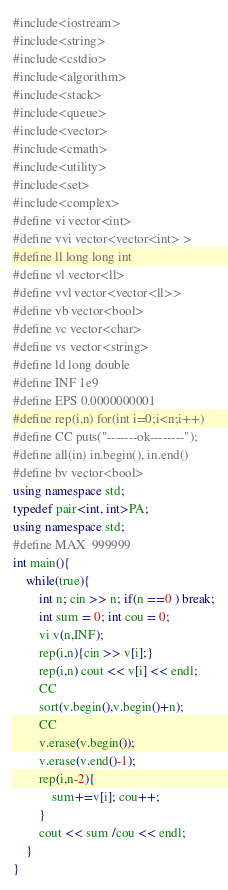Convert code to text. <code><loc_0><loc_0><loc_500><loc_500><_C++_>#include<iostream>
#include<string>
#include<cstdio>
#include<algorithm>
#include<stack>
#include<queue>
#include<vector>
#include<cmath>
#include<utility>
#include<set>
#include<complex>
#define vi vector<int>
#define vvi vector<vector<int> >
#define ll long long int
#define vl vector<ll>
#define vvl vector<vector<ll>>
#define vb vector<bool>
#define vc vector<char>
#define vs vector<string>
#define ld long double
#define INF 1e9
#define EPS 0.0000000001
#define rep(i,n) for(int i=0;i<n;i++)
#define CC puts("-------ok--------");
#define all(in) in.begin(), in.end()
#define bv vector<bool>
using namespace std;
typedef pair<int, int>PA;
using namespace std;
#define MAX  999999
int main(){
    while(true){
        int n; cin >> n; if(n ==0 ) break;
        int sum = 0; int cou = 0;
        vi v(n,INF);
        rep(i,n){cin >> v[i];}
        rep(i,n) cout << v[i] << endl;
        CC
        sort(v.begin(),v.begin()+n);
        CC
        v.erase(v.begin());
        v.erase(v.end()-1);
        rep(i,n-2){
            sum+=v[i]; cou++;
        }
        cout << sum /cou << endl;
    }
}</code> 